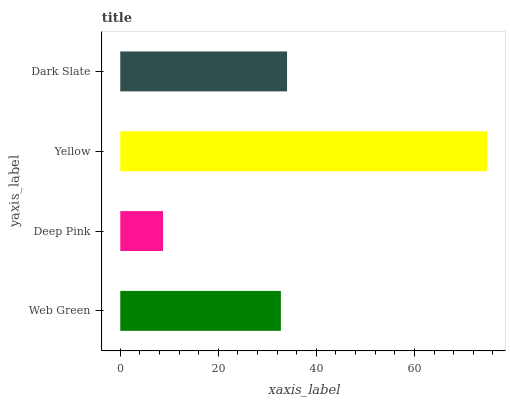Is Deep Pink the minimum?
Answer yes or no. Yes. Is Yellow the maximum?
Answer yes or no. Yes. Is Yellow the minimum?
Answer yes or no. No. Is Deep Pink the maximum?
Answer yes or no. No. Is Yellow greater than Deep Pink?
Answer yes or no. Yes. Is Deep Pink less than Yellow?
Answer yes or no. Yes. Is Deep Pink greater than Yellow?
Answer yes or no. No. Is Yellow less than Deep Pink?
Answer yes or no. No. Is Dark Slate the high median?
Answer yes or no. Yes. Is Web Green the low median?
Answer yes or no. Yes. Is Deep Pink the high median?
Answer yes or no. No. Is Deep Pink the low median?
Answer yes or no. No. 